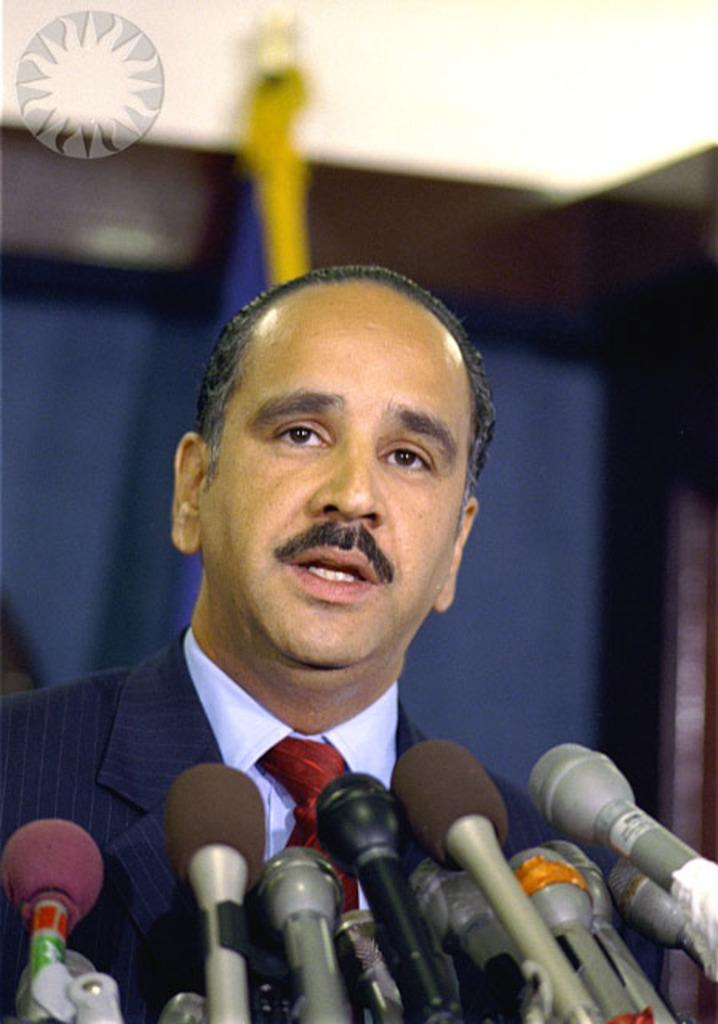Who is present in the image? There is a man in the image. What objects are at the bottom of the image? There are mics at the bottom of the image. What can be seen in the background of the image? There is a wall and a flag in the background of the image. How many tickets does the man have in the image? There is no mention of tickets in the image, so it cannot be determined if the man has any. 